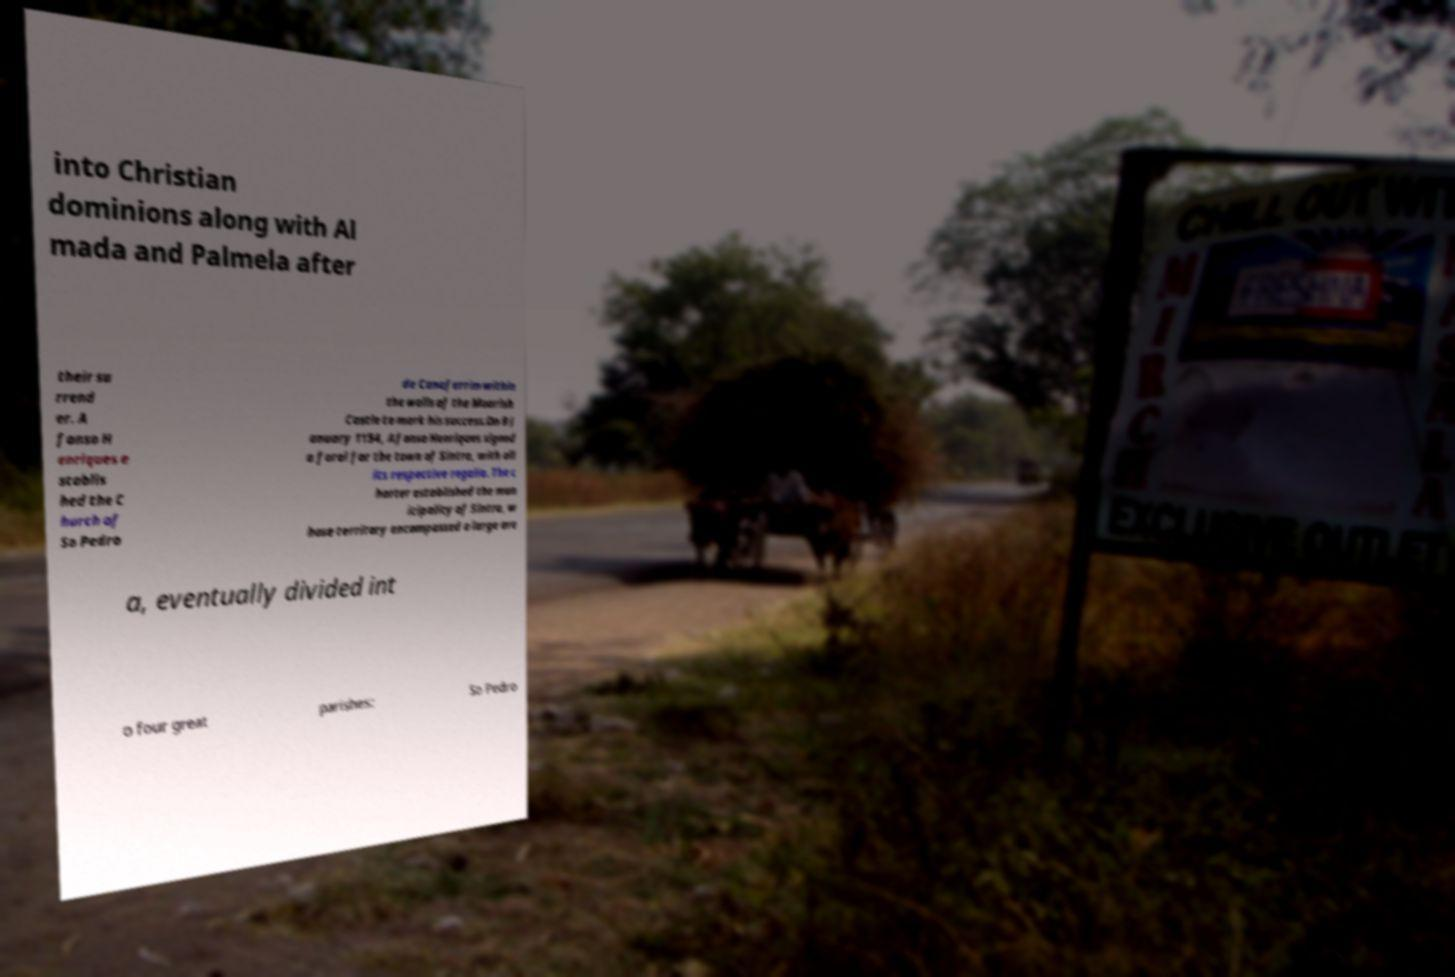Please identify and transcribe the text found in this image. into Christian dominions along with Al mada and Palmela after their su rrend er. A fonso H enriques e stablis hed the C hurch of So Pedro de Canaferrim within the walls of the Moorish Castle to mark his success.On 9 J anuary 1154, Afonso Henriques signed a foral for the town of Sintra, with all its respective regalia. The c harter established the mun icipality of Sintra, w hose territory encompassed a large are a, eventually divided int o four great parishes: So Pedro 